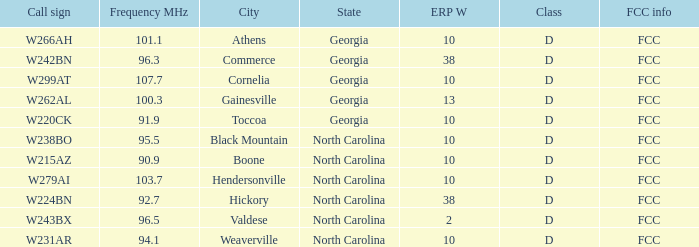What is the FCC frequency for the station w262al which has a Frequency MHz larger than 92.7? FCC. 